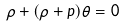Convert formula to latex. <formula><loc_0><loc_0><loc_500><loc_500>\dot { \rho } + ( \rho + p ) \theta = 0</formula> 